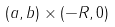<formula> <loc_0><loc_0><loc_500><loc_500>( a , b ) \times ( - R , 0 )</formula> 